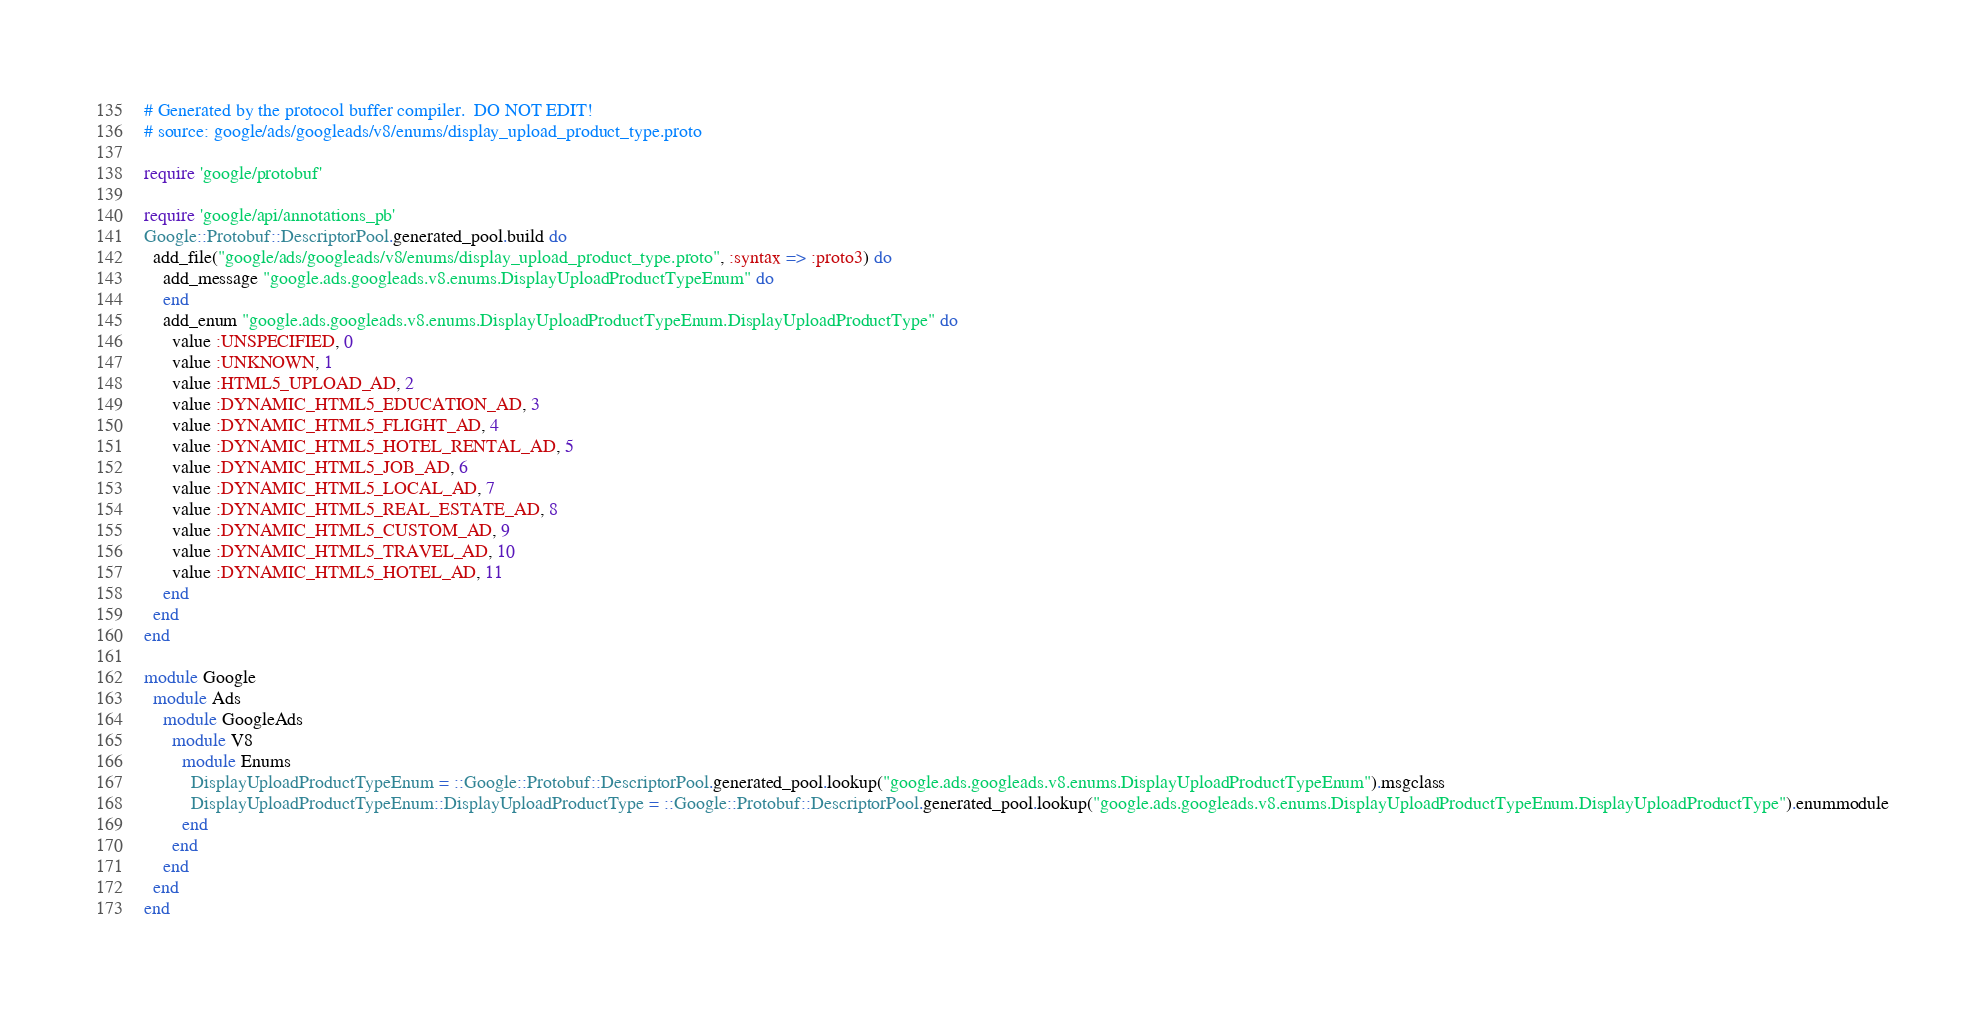Convert code to text. <code><loc_0><loc_0><loc_500><loc_500><_Ruby_># Generated by the protocol buffer compiler.  DO NOT EDIT!
# source: google/ads/googleads/v8/enums/display_upload_product_type.proto

require 'google/protobuf'

require 'google/api/annotations_pb'
Google::Protobuf::DescriptorPool.generated_pool.build do
  add_file("google/ads/googleads/v8/enums/display_upload_product_type.proto", :syntax => :proto3) do
    add_message "google.ads.googleads.v8.enums.DisplayUploadProductTypeEnum" do
    end
    add_enum "google.ads.googleads.v8.enums.DisplayUploadProductTypeEnum.DisplayUploadProductType" do
      value :UNSPECIFIED, 0
      value :UNKNOWN, 1
      value :HTML5_UPLOAD_AD, 2
      value :DYNAMIC_HTML5_EDUCATION_AD, 3
      value :DYNAMIC_HTML5_FLIGHT_AD, 4
      value :DYNAMIC_HTML5_HOTEL_RENTAL_AD, 5
      value :DYNAMIC_HTML5_JOB_AD, 6
      value :DYNAMIC_HTML5_LOCAL_AD, 7
      value :DYNAMIC_HTML5_REAL_ESTATE_AD, 8
      value :DYNAMIC_HTML5_CUSTOM_AD, 9
      value :DYNAMIC_HTML5_TRAVEL_AD, 10
      value :DYNAMIC_HTML5_HOTEL_AD, 11
    end
  end
end

module Google
  module Ads
    module GoogleAds
      module V8
        module Enums
          DisplayUploadProductTypeEnum = ::Google::Protobuf::DescriptorPool.generated_pool.lookup("google.ads.googleads.v8.enums.DisplayUploadProductTypeEnum").msgclass
          DisplayUploadProductTypeEnum::DisplayUploadProductType = ::Google::Protobuf::DescriptorPool.generated_pool.lookup("google.ads.googleads.v8.enums.DisplayUploadProductTypeEnum.DisplayUploadProductType").enummodule
        end
      end
    end
  end
end
</code> 